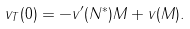Convert formula to latex. <formula><loc_0><loc_0><loc_500><loc_500>v _ { T } ( 0 ) = - v ^ { \prime } ( N ^ { * } ) M + v ( M ) .</formula> 